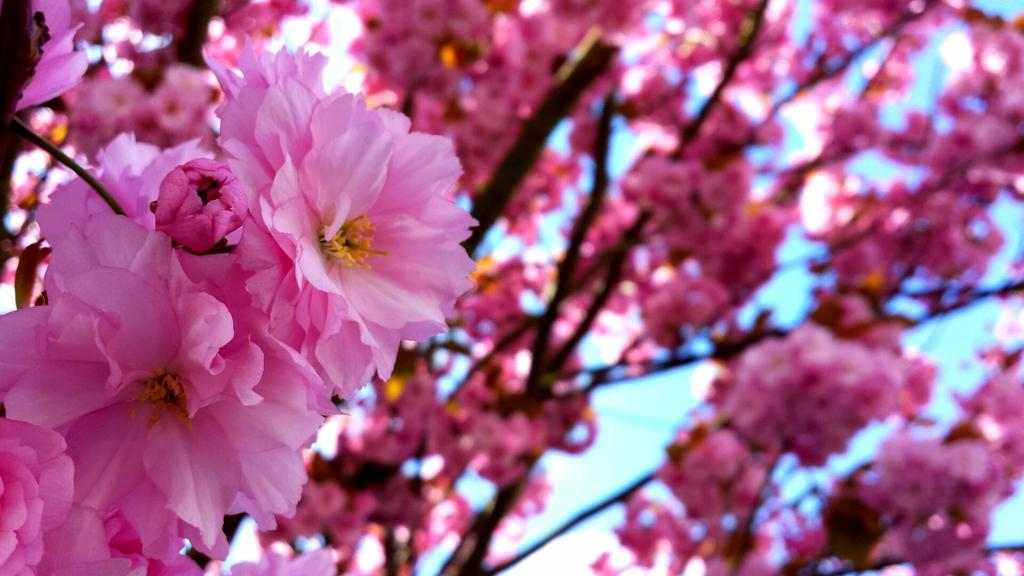What type of flowers can be seen in the image? There are pink color flowers in the image. Can you solve the riddle about the cat in the image? There is no cat present in the image, and therefore no riddle about a cat can be solved. 